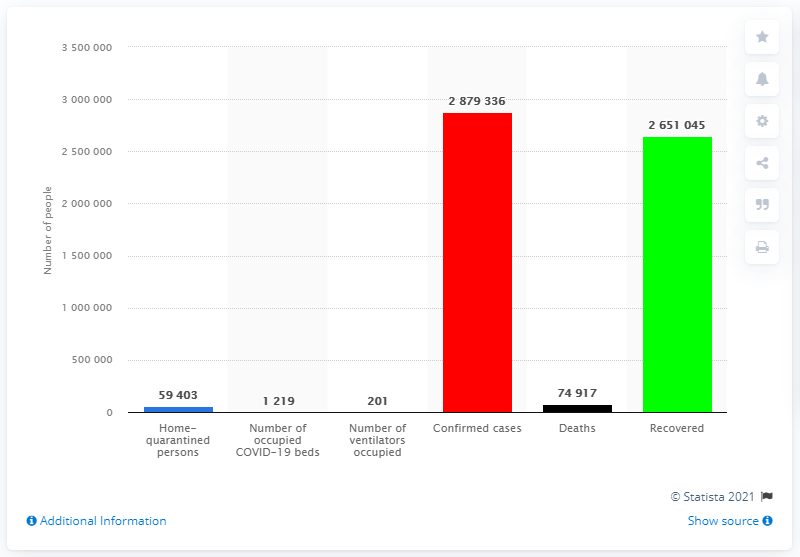List a handful of essential elements in this visual. As of June 2021, a total of 2879336 patients had been infected with the coronavirus. The number of infected patients who died was 74,917. 